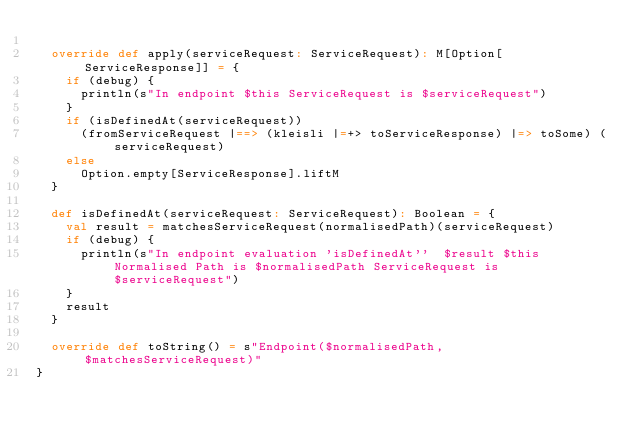Convert code to text. <code><loc_0><loc_0><loc_500><loc_500><_Scala_>
  override def apply(serviceRequest: ServiceRequest): M[Option[ServiceResponse]] = {
    if (debug) {
      println(s"In endpoint $this ServiceRequest is $serviceRequest")
    }
    if (isDefinedAt(serviceRequest))
      (fromServiceRequest |==> (kleisli |=+> toServiceResponse) |=> toSome) (serviceRequest)
    else
      Option.empty[ServiceResponse].liftM
  }

  def isDefinedAt(serviceRequest: ServiceRequest): Boolean = {
    val result = matchesServiceRequest(normalisedPath)(serviceRequest)
    if (debug) {
      println(s"In endpoint evaluation 'isDefinedAt''  $result $this Normalised Path is $normalisedPath ServiceRequest is $serviceRequest")
    }
    result
  }

  override def toString() = s"Endpoint($normalisedPath, $matchesServiceRequest)"
}



</code> 